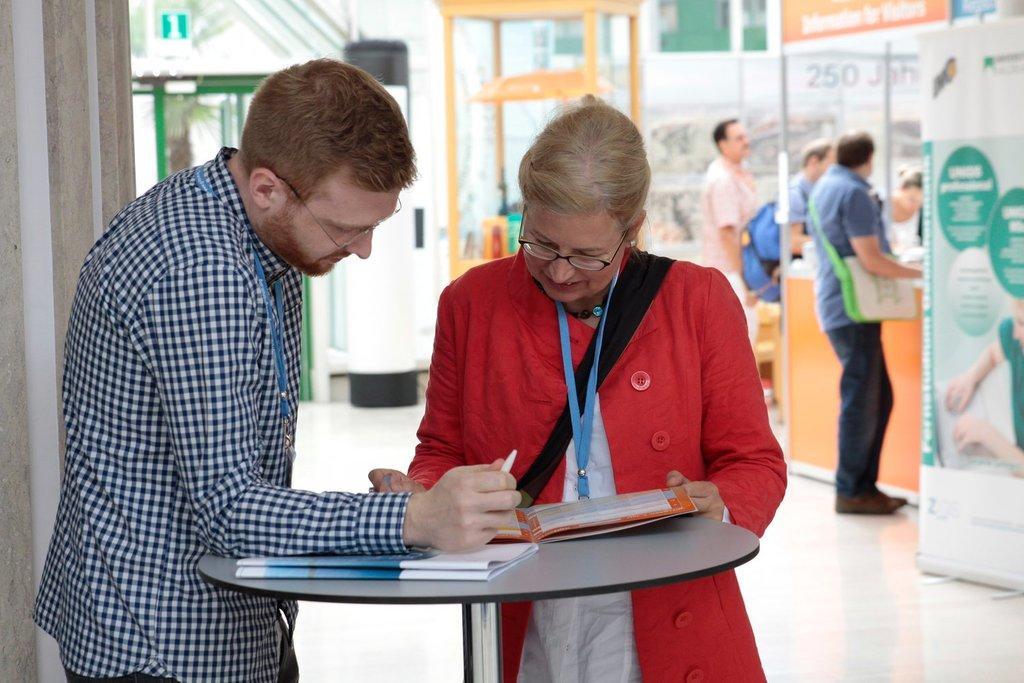Could you give a brief overview of what you see in this image? In this picture we can see 2 people standing near a round table and going through a file. In the background, we can see other people standing. 